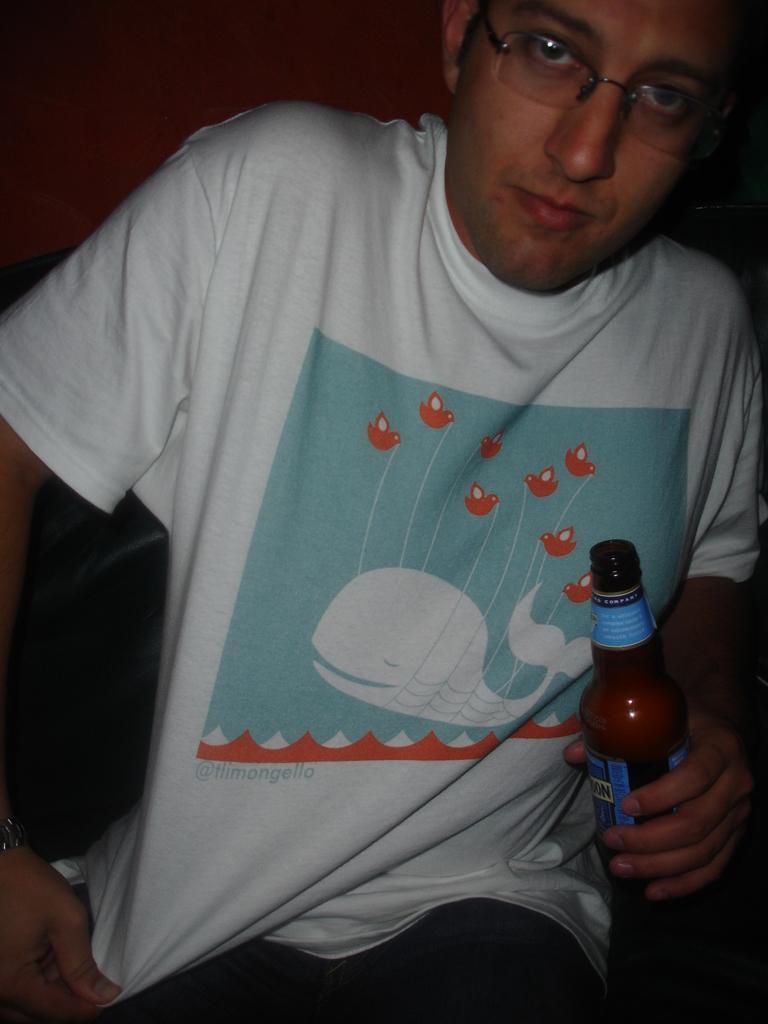Describe this image in one or two sentences. This picture shows a man seated and holding a beer bottle in his hand 